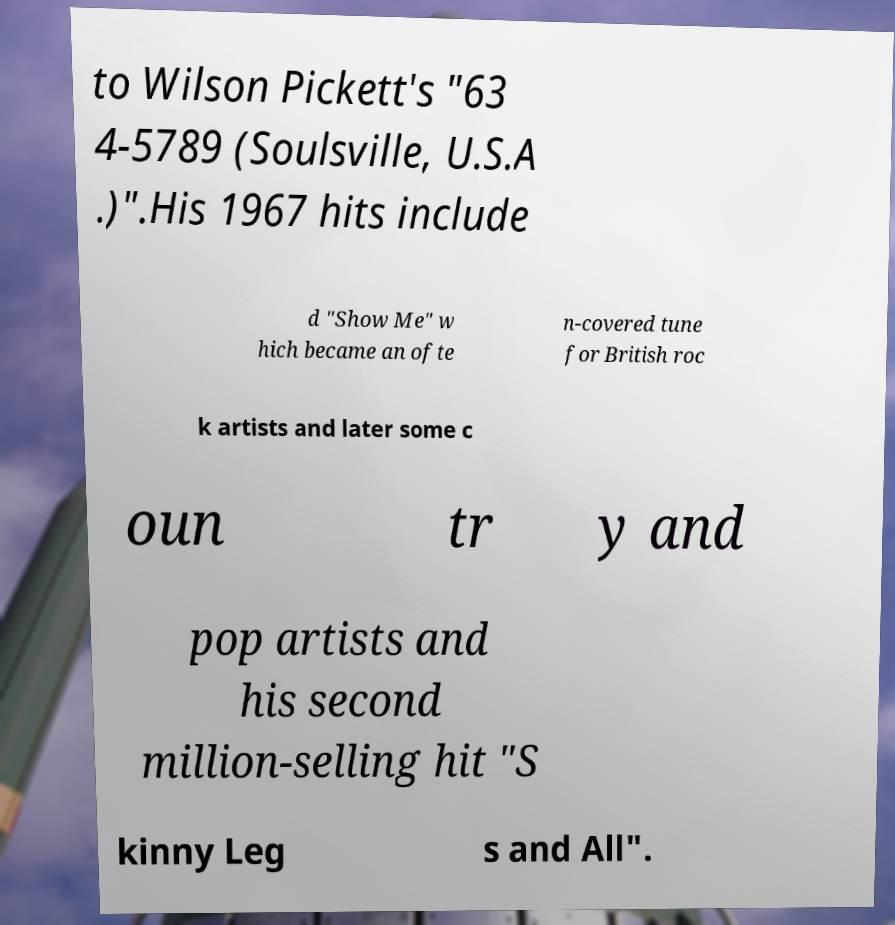Please identify and transcribe the text found in this image. to Wilson Pickett's "63 4-5789 (Soulsville, U.S.A .)".His 1967 hits include d "Show Me" w hich became an ofte n-covered tune for British roc k artists and later some c oun tr y and pop artists and his second million-selling hit "S kinny Leg s and All". 